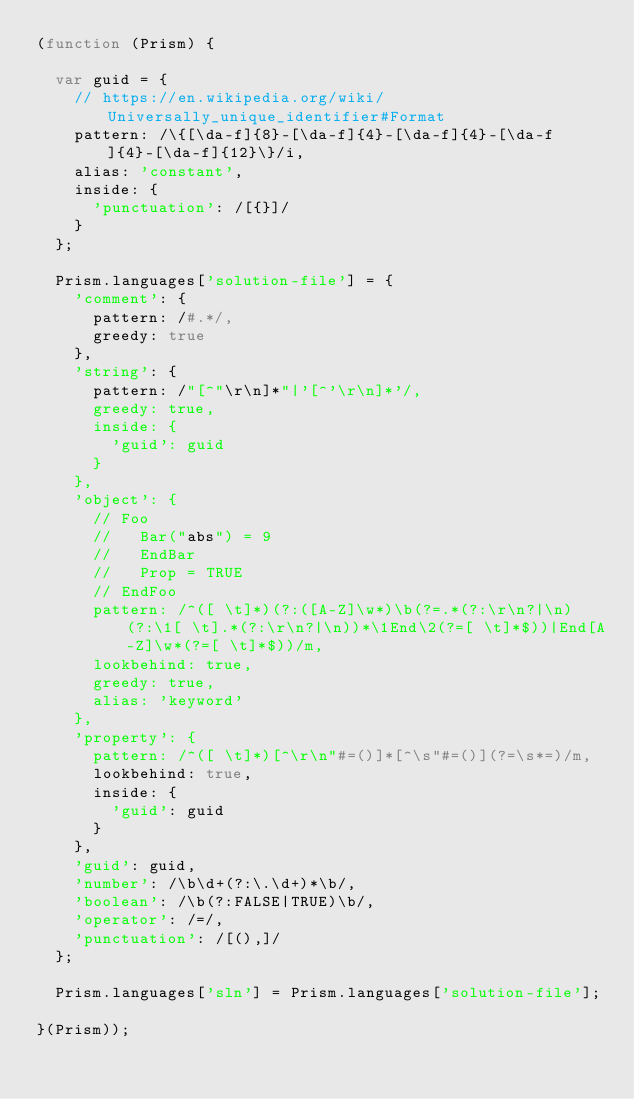Convert code to text. <code><loc_0><loc_0><loc_500><loc_500><_JavaScript_>(function (Prism) {
  
  var guid = {
    // https://en.wikipedia.org/wiki/Universally_unique_identifier#Format
    pattern: /\{[\da-f]{8}-[\da-f]{4}-[\da-f]{4}-[\da-f]{4}-[\da-f]{12}\}/i,
    alias: 'constant',
    inside: {
      'punctuation': /[{}]/
    }
  };
  
  Prism.languages['solution-file'] = {
    'comment': {
      pattern: /#.*/,
      greedy: true
    },
    'string': {
      pattern: /"[^"\r\n]*"|'[^'\r\n]*'/,
      greedy: true,
      inside: {
        'guid': guid
      }
    },
    'object': {
      // Foo
      //   Bar("abs") = 9
      //   EndBar
      //   Prop = TRUE
      // EndFoo
      pattern: /^([ \t]*)(?:([A-Z]\w*)\b(?=.*(?:\r\n?|\n)(?:\1[ \t].*(?:\r\n?|\n))*\1End\2(?=[ \t]*$))|End[A-Z]\w*(?=[ \t]*$))/m,
      lookbehind: true,
      greedy: true,
      alias: 'keyword'
    },
    'property': {
      pattern: /^([ \t]*)[^\r\n"#=()]*[^\s"#=()](?=\s*=)/m,
      lookbehind: true,
      inside: {
        'guid': guid
      }
    },
    'guid': guid,
    'number': /\b\d+(?:\.\d+)*\b/,
    'boolean': /\b(?:FALSE|TRUE)\b/,
    'operator': /=/,
    'punctuation': /[(),]/
  };
  
  Prism.languages['sln'] = Prism.languages['solution-file'];
  
}(Prism));
</code> 